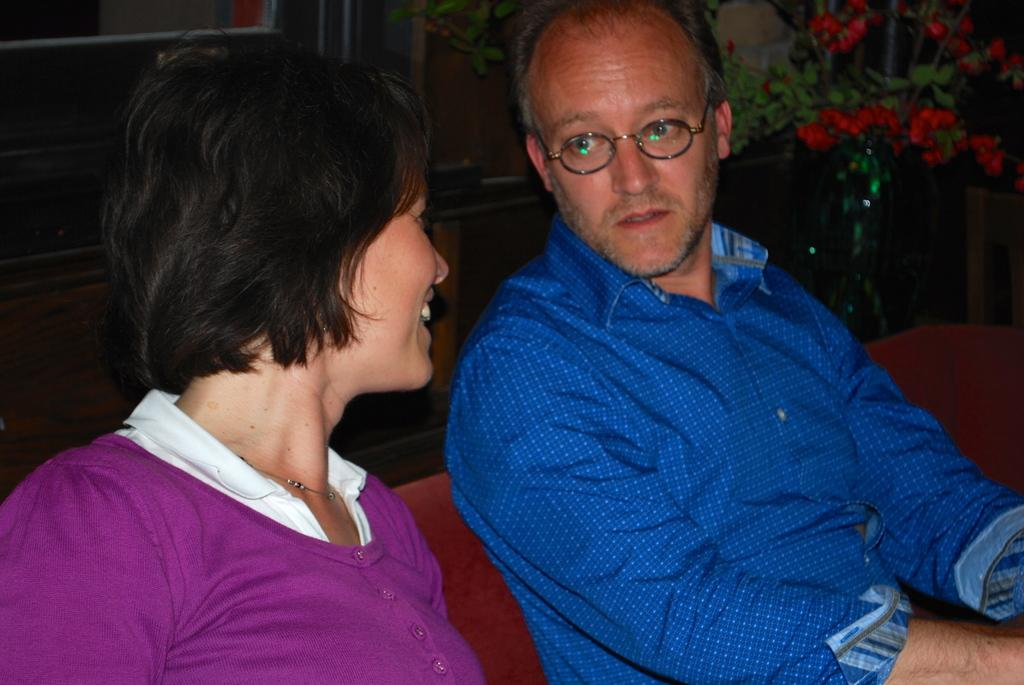What are the people in the image doing? The people in the image are seated. What type of plant can be seen in the image? There is a plant with flowers in the image. Can you describe the appearance of one of the people in the image? A man is wearing spectacles. What type of chain can be seen around the neck of the plant in the image? There is no chain present around the neck of the plant in the image. 